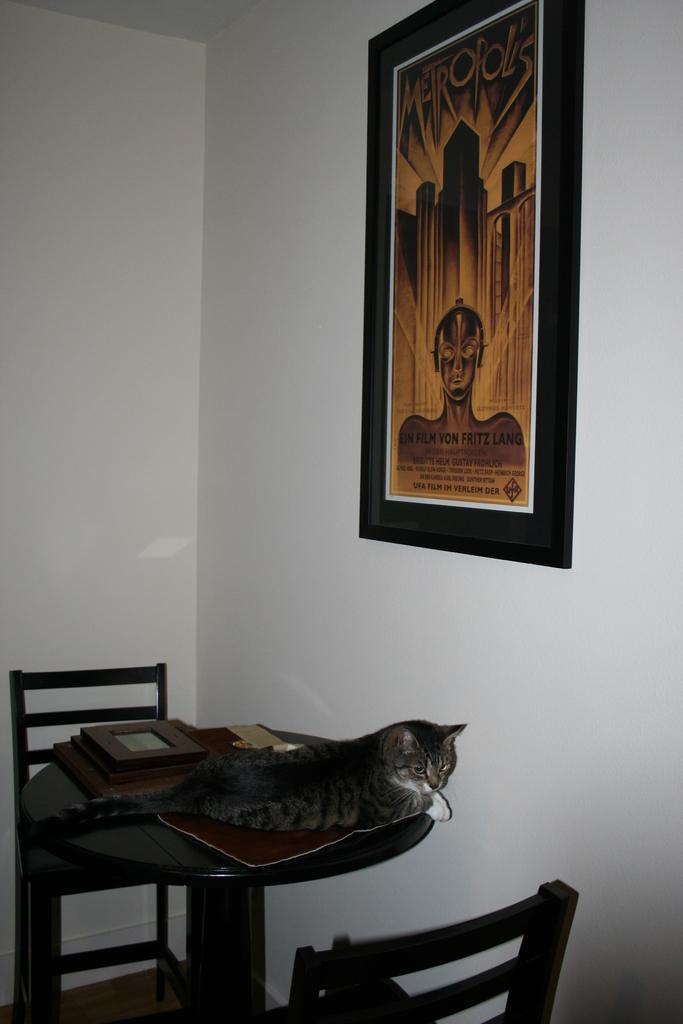Where is the image taken? The image is taken in a room. What animal can be seen in the image? There is a cat sitting on the table in the image. What furniture is present in the room? There are chairs in the room. What is behind the table in the image? There is a wall behind the table. What decorative item is on the wall? There is a photo frame on the wall. What type of cough is the cat experiencing in the image? There is no indication in the image that the cat is experiencing a cough, and therefore it cannot be determined from the image. 